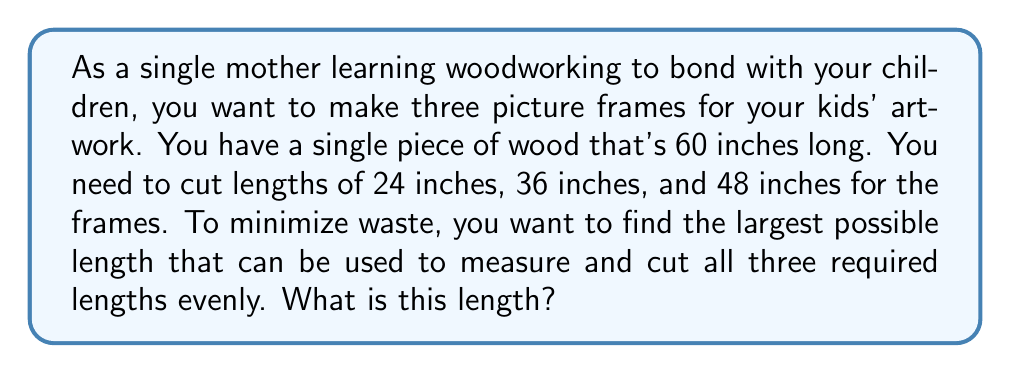Solve this math problem. To solve this problem, we need to find the greatest common divisor (GCD) of the required lengths: 24 inches, 36 inches, and 48 inches. This will give us the largest possible length that evenly divides all three measurements, allowing us to minimize waste when cutting the wood.

Let's use the Euclidean algorithm to find the GCD:

1) First, let's find the GCD of 24 and 36:
   $$ 36 = 1 \times 24 + 12 $$
   $$ 24 = 2 \times 12 + 0 $$
   So, $GCD(24, 36) = 12$

2) Now, let's find the GCD of this result (12) and 48:
   $$ 48 = 4 \times 12 + 0 $$

Therefore, the GCD of 24, 36, and 48 is 12.

This means that 12 inches is the largest length that can evenly divide all three required lengths:
- 24 inches = 2 × 12 inches
- 36 inches = 3 × 12 inches
- 48 inches = 4 × 12 inches

By using a 12-inch measurement, you can cut the 60-inch board into five 12-inch sections, which can then be combined as needed for each frame, minimizing waste.
Answer: The largest possible length that can be used to measure and cut all three required lengths evenly is 12 inches. 